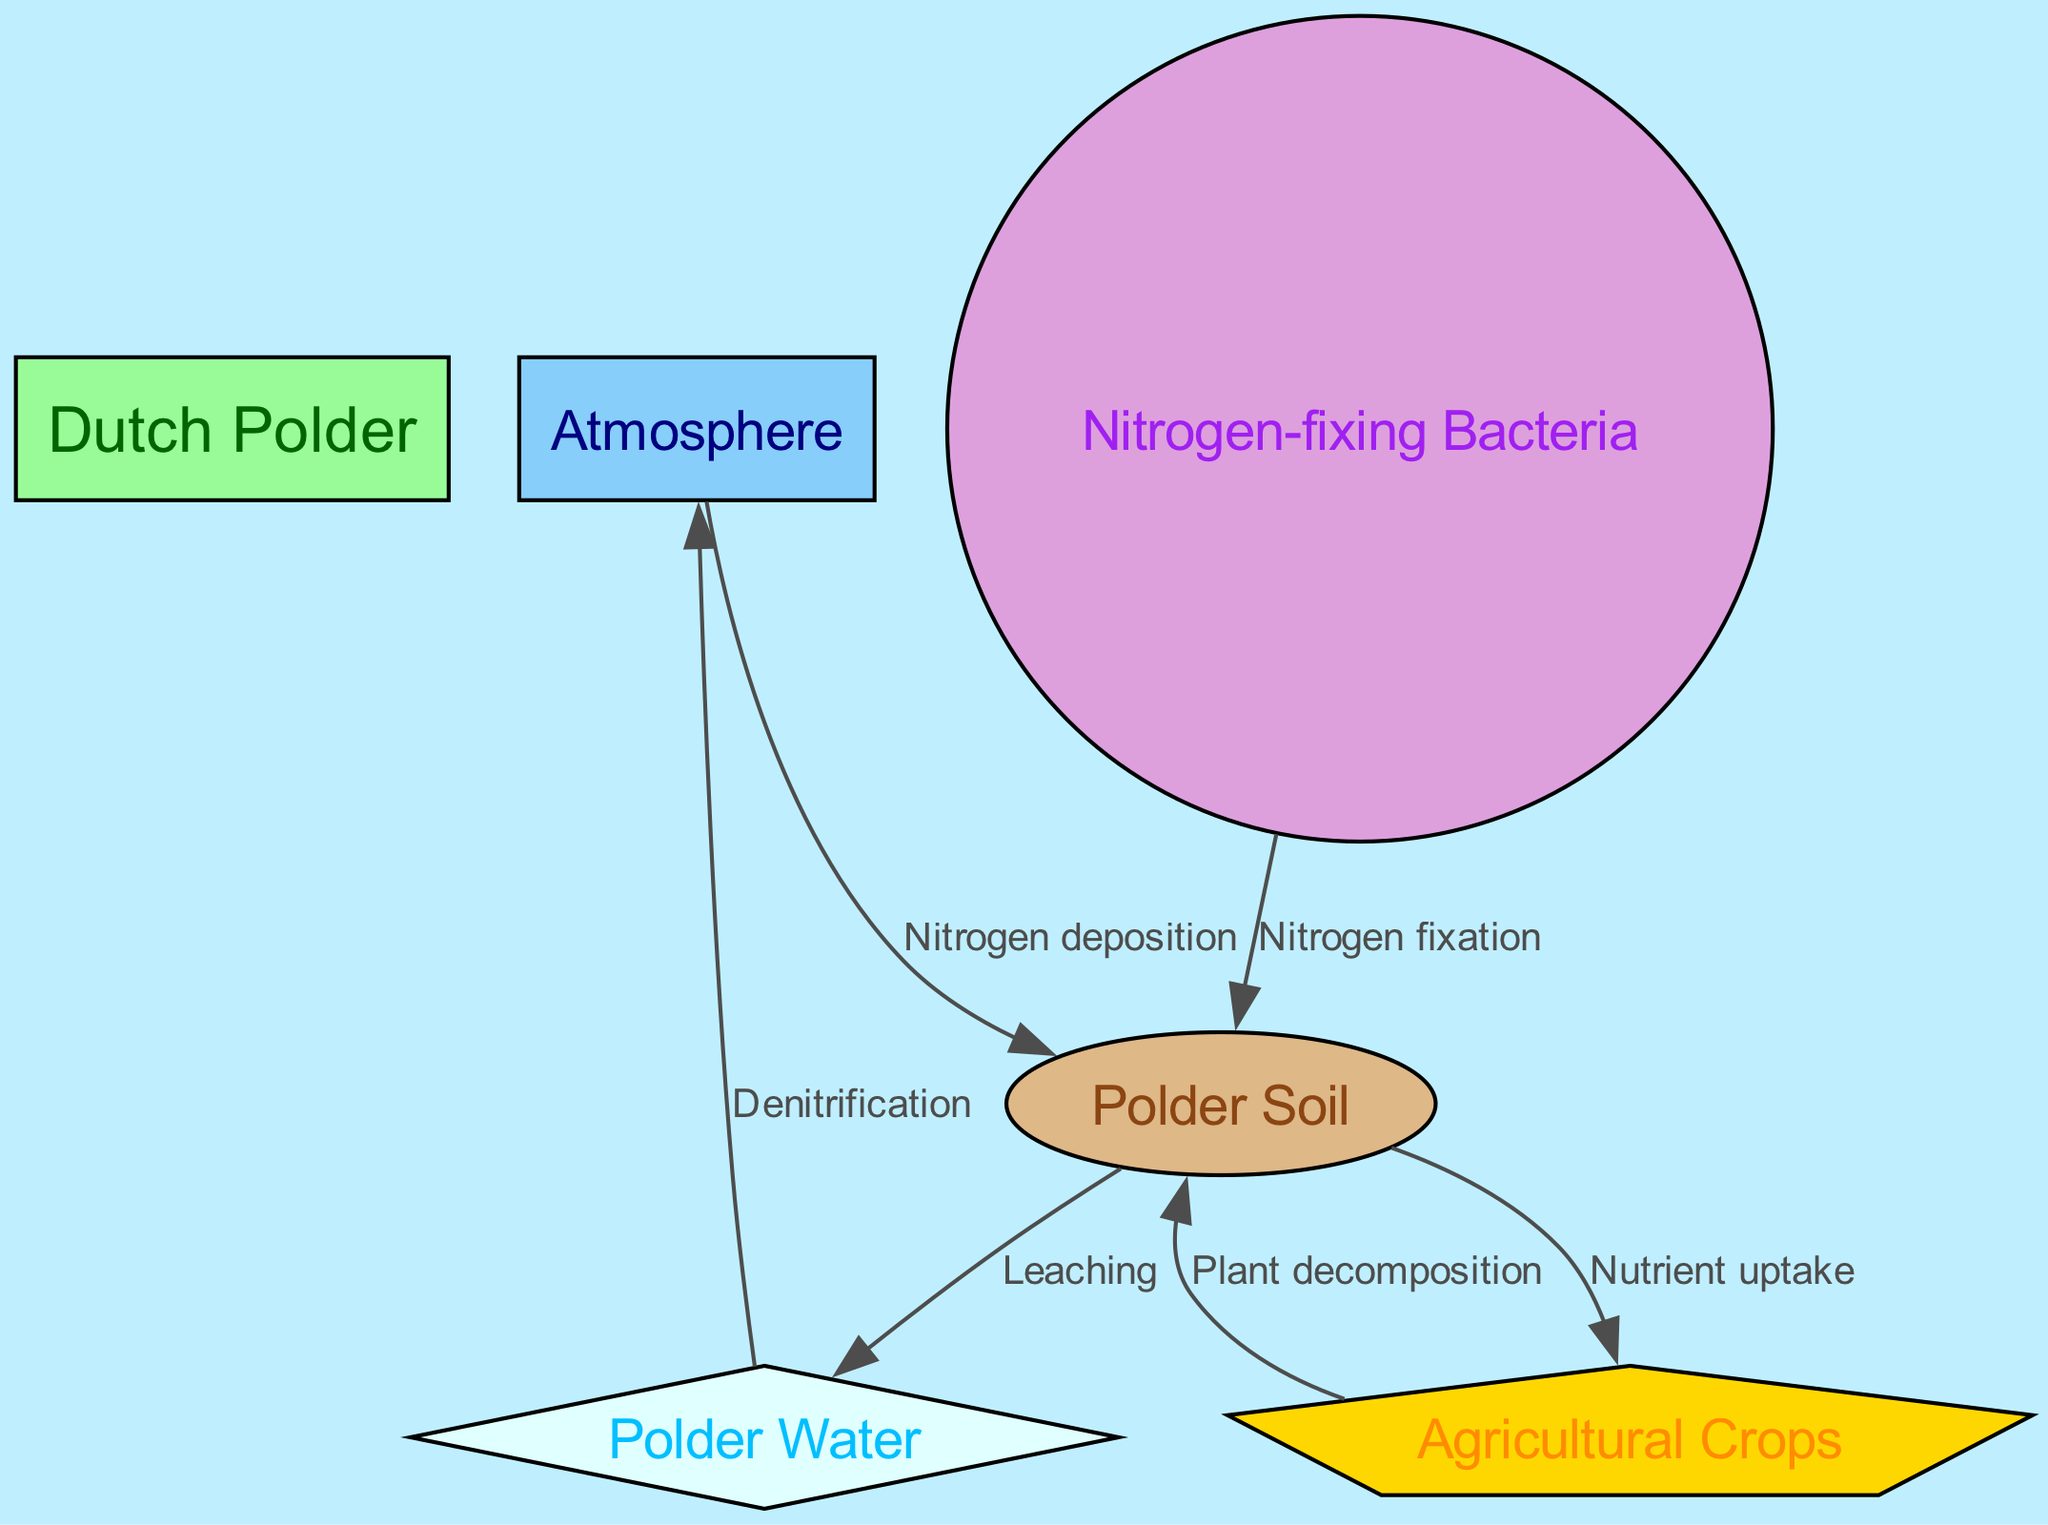What is the total number of nodes in the diagram? The diagram has a total of six nodes, which are: Dutch Polder, Atmosphere, Agricultural Crops, Polder Soil, Polder Water, and Nitrogen-fixing Bacteria.
Answer: 6 What type of connection exists between the Atmosphere and Polder Soil? The connection between the Atmosphere and Polder Soil is labeled as "Nitrogen deposition," indicating that nitrogen is deposited from the atmosphere to the soil.
Answer: Nitrogen deposition Which component is responsible for nitrogen fixation in the soil? The component responsible for nitrogen fixation in the soil is Nitrogen-fixing Bacteria, as indicated by the directed edge from bacteria to soil labeled as "Nitrogen fixation."
Answer: Nitrogen-fixing Bacteria How many edges are connecting nodes directly to Polder Soil? Polder Soil is connected to four edges leading to Agricultural Crops, Polder Water, Nitrogen-fixing Bacteria, and from Agricultural Crops back to Polder Soil through Plant decomposition.
Answer: 4 What process leads to nitrogen being released back into the Atmosphere from Polder Water? The process that leads to nitrogen being released back into the Atmosphere from Polder Water is labeled as "Denitrification." This indicates that bacteria convert nitrates into nitrogen gas, which is then released into the atmosphere.
Answer: Denitrification What is the flow direction of nitrogen from Agricultural Crops back to Polder Soil? The flow direction of nitrogen from Agricultural Crops back to Polder Soil is through the process labeled "Plant decomposition," which illustrates that when crops die or are decomposed, nitrogen returns to the soil.
Answer: Plant decomposition Which node receives nitrogen directly from the soil? The node that receives nitrogen directly from the soil is Agricultural Crops, as indicated by the edge labeled "Nutrient uptake" showing the flow of resources from soil to crops.
Answer: Agricultural Crops 